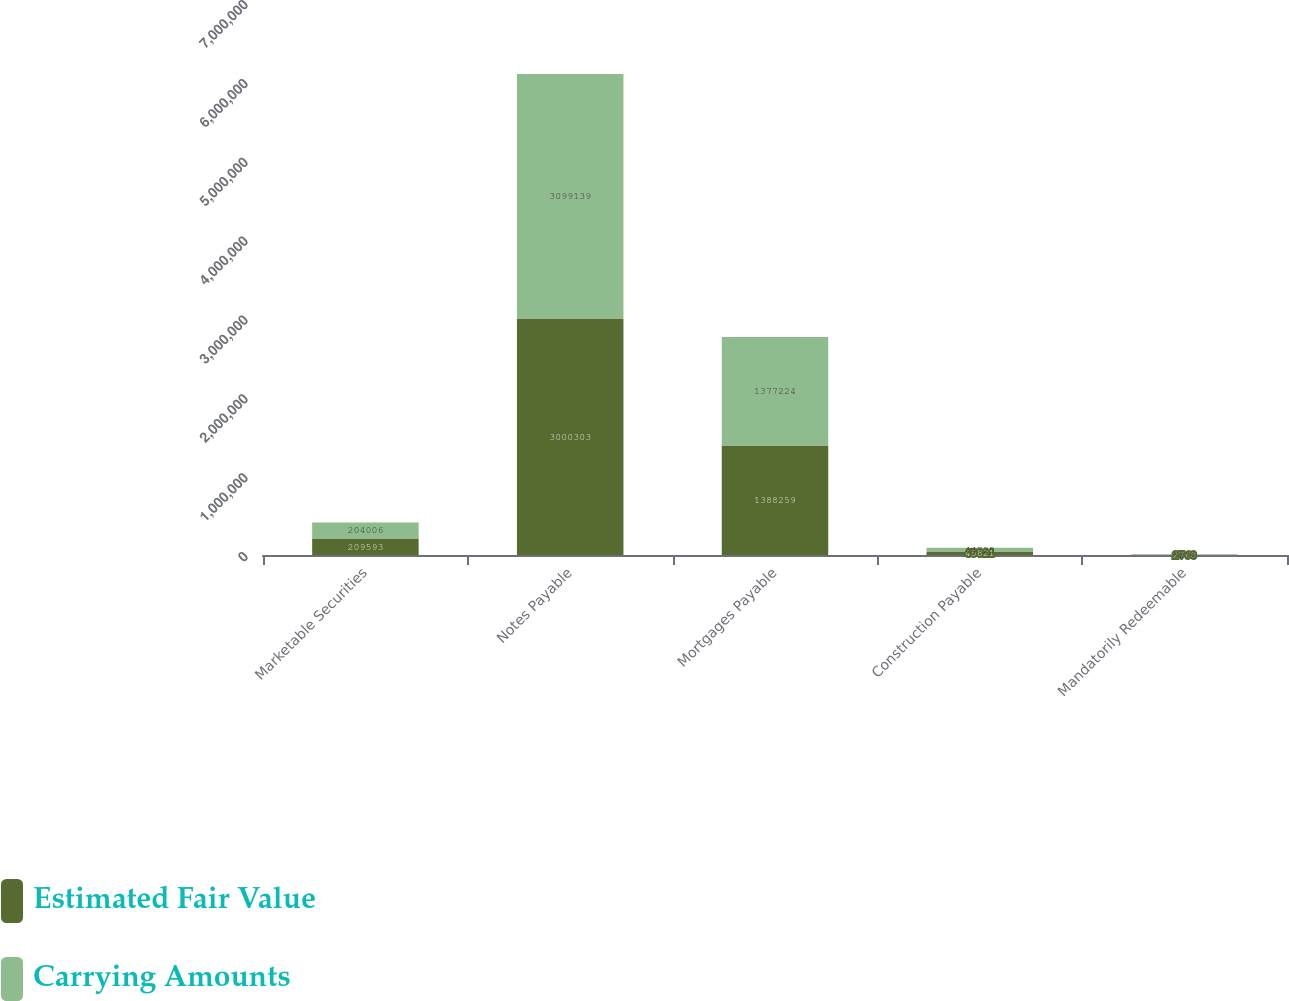Convert chart. <chart><loc_0><loc_0><loc_500><loc_500><stacked_bar_chart><ecel><fcel>Marketable Securities<fcel>Notes Payable<fcel>Mortgages Payable<fcel>Construction Payable<fcel>Mandatorily Redeemable<nl><fcel>Estimated Fair Value<fcel>209593<fcel>3.0003e+06<fcel>1.38826e+06<fcel>45821<fcel>2768<nl><fcel>Carrying Amounts<fcel>204006<fcel>3.09914e+06<fcel>1.37722e+06<fcel>44725<fcel>5256<nl></chart> 